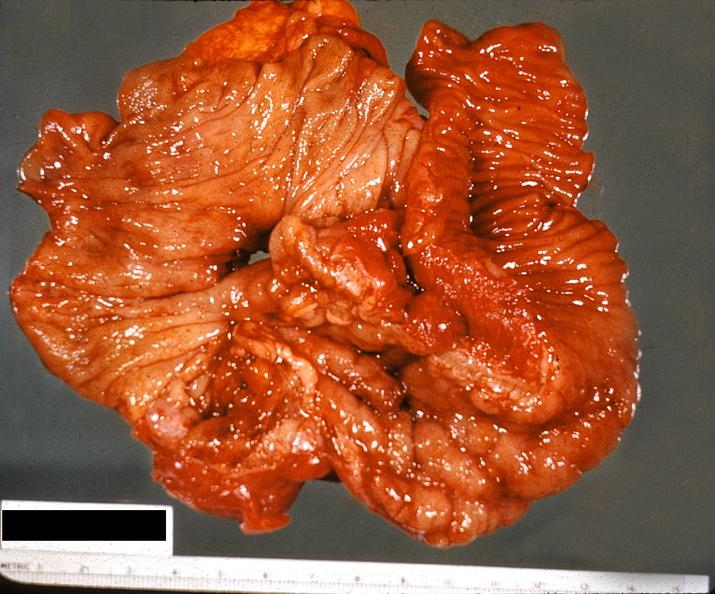s gastrointestinal present?
Answer the question using a single word or phrase. Yes 